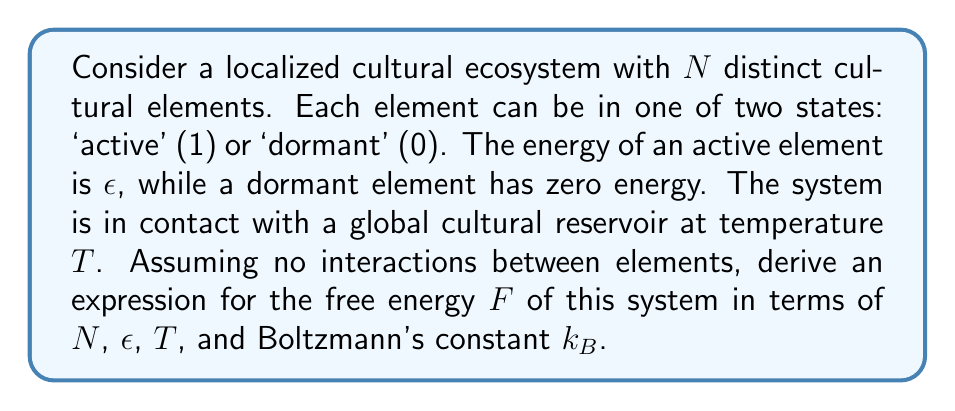Can you answer this question? 1. The partition function $Z$ for a single cultural element is:
   $$Z_1 = e^{-\epsilon/k_BT} + 1$$

2. For $N$ independent elements, the total partition function is:
   $$Z = (e^{-\epsilon/k_BT} + 1)^N$$

3. The free energy $F$ is related to the partition function by:
   $$F = -k_BT \ln Z$$

4. Substituting the expression for $Z$:
   $$F = -k_BT \ln (e^{-\epsilon/k_BT} + 1)^N$$

5. Using the properties of logarithms:
   $$F = -Nk_BT \ln (e^{-\epsilon/k_BT} + 1)$$

This expression represents the free energy of the localized cultural ecosystem, balancing the energy of active elements with the entropy of the system.
Answer: $$F = -Nk_BT \ln (e^{-\epsilon/k_BT} + 1)$$ 